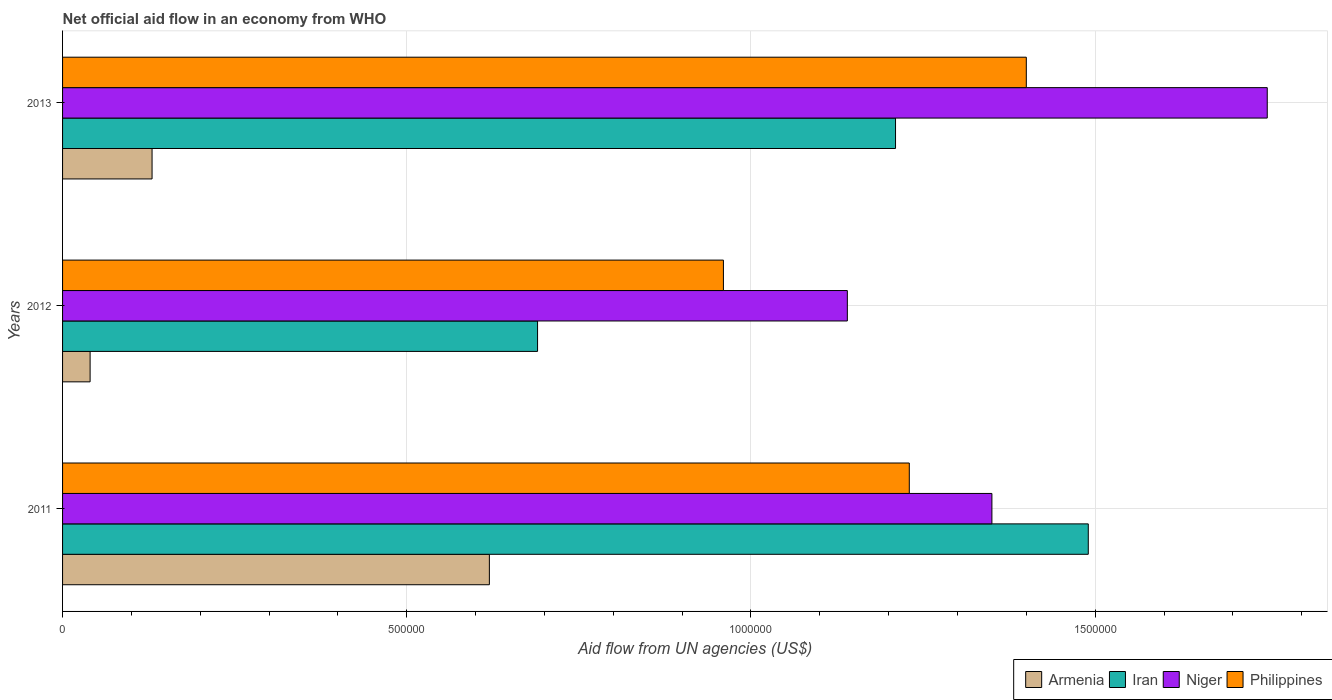How many different coloured bars are there?
Offer a very short reply. 4. Are the number of bars on each tick of the Y-axis equal?
Make the answer very short. Yes. How many bars are there on the 3rd tick from the top?
Give a very brief answer. 4. What is the label of the 3rd group of bars from the top?
Your response must be concise. 2011. What is the net official aid flow in Iran in 2013?
Offer a terse response. 1.21e+06. Across all years, what is the maximum net official aid flow in Iran?
Your answer should be compact. 1.49e+06. Across all years, what is the minimum net official aid flow in Iran?
Give a very brief answer. 6.90e+05. In which year was the net official aid flow in Niger maximum?
Offer a very short reply. 2013. What is the total net official aid flow in Philippines in the graph?
Provide a short and direct response. 3.59e+06. What is the difference between the net official aid flow in Philippines in 2013 and the net official aid flow in Iran in 2012?
Offer a very short reply. 7.10e+05. What is the average net official aid flow in Philippines per year?
Give a very brief answer. 1.20e+06. In the year 2012, what is the difference between the net official aid flow in Armenia and net official aid flow in Niger?
Your answer should be very brief. -1.10e+06. What is the ratio of the net official aid flow in Armenia in 2012 to that in 2013?
Your answer should be compact. 0.31. Is the difference between the net official aid flow in Armenia in 2011 and 2013 greater than the difference between the net official aid flow in Niger in 2011 and 2013?
Offer a very short reply. Yes. What is the difference between the highest and the lowest net official aid flow in Philippines?
Keep it short and to the point. 4.40e+05. What does the 4th bar from the top in 2011 represents?
Give a very brief answer. Armenia. What does the 4th bar from the bottom in 2013 represents?
Your answer should be very brief. Philippines. How many bars are there?
Offer a very short reply. 12. How many years are there in the graph?
Offer a terse response. 3. What is the difference between two consecutive major ticks on the X-axis?
Your response must be concise. 5.00e+05. Does the graph contain grids?
Your response must be concise. Yes. How are the legend labels stacked?
Offer a very short reply. Horizontal. What is the title of the graph?
Provide a short and direct response. Net official aid flow in an economy from WHO. Does "Other small states" appear as one of the legend labels in the graph?
Give a very brief answer. No. What is the label or title of the X-axis?
Provide a succinct answer. Aid flow from UN agencies (US$). What is the Aid flow from UN agencies (US$) of Armenia in 2011?
Your answer should be very brief. 6.20e+05. What is the Aid flow from UN agencies (US$) of Iran in 2011?
Offer a very short reply. 1.49e+06. What is the Aid flow from UN agencies (US$) in Niger in 2011?
Provide a succinct answer. 1.35e+06. What is the Aid flow from UN agencies (US$) in Philippines in 2011?
Make the answer very short. 1.23e+06. What is the Aid flow from UN agencies (US$) of Iran in 2012?
Ensure brevity in your answer.  6.90e+05. What is the Aid flow from UN agencies (US$) of Niger in 2012?
Make the answer very short. 1.14e+06. What is the Aid flow from UN agencies (US$) of Philippines in 2012?
Give a very brief answer. 9.60e+05. What is the Aid flow from UN agencies (US$) in Armenia in 2013?
Ensure brevity in your answer.  1.30e+05. What is the Aid flow from UN agencies (US$) in Iran in 2013?
Your response must be concise. 1.21e+06. What is the Aid flow from UN agencies (US$) in Niger in 2013?
Ensure brevity in your answer.  1.75e+06. What is the Aid flow from UN agencies (US$) of Philippines in 2013?
Offer a terse response. 1.40e+06. Across all years, what is the maximum Aid flow from UN agencies (US$) of Armenia?
Make the answer very short. 6.20e+05. Across all years, what is the maximum Aid flow from UN agencies (US$) in Iran?
Provide a succinct answer. 1.49e+06. Across all years, what is the maximum Aid flow from UN agencies (US$) in Niger?
Ensure brevity in your answer.  1.75e+06. Across all years, what is the maximum Aid flow from UN agencies (US$) of Philippines?
Your answer should be very brief. 1.40e+06. Across all years, what is the minimum Aid flow from UN agencies (US$) in Iran?
Make the answer very short. 6.90e+05. Across all years, what is the minimum Aid flow from UN agencies (US$) in Niger?
Ensure brevity in your answer.  1.14e+06. Across all years, what is the minimum Aid flow from UN agencies (US$) of Philippines?
Your answer should be compact. 9.60e+05. What is the total Aid flow from UN agencies (US$) in Armenia in the graph?
Provide a short and direct response. 7.90e+05. What is the total Aid flow from UN agencies (US$) of Iran in the graph?
Make the answer very short. 3.39e+06. What is the total Aid flow from UN agencies (US$) of Niger in the graph?
Ensure brevity in your answer.  4.24e+06. What is the total Aid flow from UN agencies (US$) of Philippines in the graph?
Ensure brevity in your answer.  3.59e+06. What is the difference between the Aid flow from UN agencies (US$) in Armenia in 2011 and that in 2012?
Offer a terse response. 5.80e+05. What is the difference between the Aid flow from UN agencies (US$) of Iran in 2011 and that in 2012?
Your answer should be very brief. 8.00e+05. What is the difference between the Aid flow from UN agencies (US$) in Philippines in 2011 and that in 2012?
Your answer should be very brief. 2.70e+05. What is the difference between the Aid flow from UN agencies (US$) in Niger in 2011 and that in 2013?
Ensure brevity in your answer.  -4.00e+05. What is the difference between the Aid flow from UN agencies (US$) of Iran in 2012 and that in 2013?
Give a very brief answer. -5.20e+05. What is the difference between the Aid flow from UN agencies (US$) in Niger in 2012 and that in 2013?
Offer a very short reply. -6.10e+05. What is the difference between the Aid flow from UN agencies (US$) in Philippines in 2012 and that in 2013?
Make the answer very short. -4.40e+05. What is the difference between the Aid flow from UN agencies (US$) of Armenia in 2011 and the Aid flow from UN agencies (US$) of Iran in 2012?
Give a very brief answer. -7.00e+04. What is the difference between the Aid flow from UN agencies (US$) of Armenia in 2011 and the Aid flow from UN agencies (US$) of Niger in 2012?
Your answer should be compact. -5.20e+05. What is the difference between the Aid flow from UN agencies (US$) in Armenia in 2011 and the Aid flow from UN agencies (US$) in Philippines in 2012?
Offer a very short reply. -3.40e+05. What is the difference between the Aid flow from UN agencies (US$) of Iran in 2011 and the Aid flow from UN agencies (US$) of Philippines in 2012?
Keep it short and to the point. 5.30e+05. What is the difference between the Aid flow from UN agencies (US$) of Niger in 2011 and the Aid flow from UN agencies (US$) of Philippines in 2012?
Ensure brevity in your answer.  3.90e+05. What is the difference between the Aid flow from UN agencies (US$) in Armenia in 2011 and the Aid flow from UN agencies (US$) in Iran in 2013?
Your response must be concise. -5.90e+05. What is the difference between the Aid flow from UN agencies (US$) of Armenia in 2011 and the Aid flow from UN agencies (US$) of Niger in 2013?
Offer a terse response. -1.13e+06. What is the difference between the Aid flow from UN agencies (US$) in Armenia in 2011 and the Aid flow from UN agencies (US$) in Philippines in 2013?
Offer a terse response. -7.80e+05. What is the difference between the Aid flow from UN agencies (US$) of Iran in 2011 and the Aid flow from UN agencies (US$) of Philippines in 2013?
Provide a short and direct response. 9.00e+04. What is the difference between the Aid flow from UN agencies (US$) of Armenia in 2012 and the Aid flow from UN agencies (US$) of Iran in 2013?
Offer a terse response. -1.17e+06. What is the difference between the Aid flow from UN agencies (US$) in Armenia in 2012 and the Aid flow from UN agencies (US$) in Niger in 2013?
Ensure brevity in your answer.  -1.71e+06. What is the difference between the Aid flow from UN agencies (US$) of Armenia in 2012 and the Aid flow from UN agencies (US$) of Philippines in 2013?
Your answer should be compact. -1.36e+06. What is the difference between the Aid flow from UN agencies (US$) in Iran in 2012 and the Aid flow from UN agencies (US$) in Niger in 2013?
Provide a short and direct response. -1.06e+06. What is the difference between the Aid flow from UN agencies (US$) in Iran in 2012 and the Aid flow from UN agencies (US$) in Philippines in 2013?
Offer a very short reply. -7.10e+05. What is the average Aid flow from UN agencies (US$) in Armenia per year?
Provide a short and direct response. 2.63e+05. What is the average Aid flow from UN agencies (US$) of Iran per year?
Your answer should be very brief. 1.13e+06. What is the average Aid flow from UN agencies (US$) of Niger per year?
Your answer should be very brief. 1.41e+06. What is the average Aid flow from UN agencies (US$) of Philippines per year?
Offer a terse response. 1.20e+06. In the year 2011, what is the difference between the Aid flow from UN agencies (US$) of Armenia and Aid flow from UN agencies (US$) of Iran?
Give a very brief answer. -8.70e+05. In the year 2011, what is the difference between the Aid flow from UN agencies (US$) of Armenia and Aid flow from UN agencies (US$) of Niger?
Give a very brief answer. -7.30e+05. In the year 2011, what is the difference between the Aid flow from UN agencies (US$) of Armenia and Aid flow from UN agencies (US$) of Philippines?
Offer a very short reply. -6.10e+05. In the year 2011, what is the difference between the Aid flow from UN agencies (US$) of Niger and Aid flow from UN agencies (US$) of Philippines?
Offer a terse response. 1.20e+05. In the year 2012, what is the difference between the Aid flow from UN agencies (US$) of Armenia and Aid flow from UN agencies (US$) of Iran?
Provide a succinct answer. -6.50e+05. In the year 2012, what is the difference between the Aid flow from UN agencies (US$) in Armenia and Aid flow from UN agencies (US$) in Niger?
Offer a very short reply. -1.10e+06. In the year 2012, what is the difference between the Aid flow from UN agencies (US$) of Armenia and Aid flow from UN agencies (US$) of Philippines?
Your answer should be compact. -9.20e+05. In the year 2012, what is the difference between the Aid flow from UN agencies (US$) of Iran and Aid flow from UN agencies (US$) of Niger?
Your answer should be compact. -4.50e+05. In the year 2013, what is the difference between the Aid flow from UN agencies (US$) in Armenia and Aid flow from UN agencies (US$) in Iran?
Your answer should be very brief. -1.08e+06. In the year 2013, what is the difference between the Aid flow from UN agencies (US$) of Armenia and Aid flow from UN agencies (US$) of Niger?
Your response must be concise. -1.62e+06. In the year 2013, what is the difference between the Aid flow from UN agencies (US$) in Armenia and Aid flow from UN agencies (US$) in Philippines?
Provide a short and direct response. -1.27e+06. In the year 2013, what is the difference between the Aid flow from UN agencies (US$) of Iran and Aid flow from UN agencies (US$) of Niger?
Keep it short and to the point. -5.40e+05. In the year 2013, what is the difference between the Aid flow from UN agencies (US$) in Iran and Aid flow from UN agencies (US$) in Philippines?
Make the answer very short. -1.90e+05. In the year 2013, what is the difference between the Aid flow from UN agencies (US$) of Niger and Aid flow from UN agencies (US$) of Philippines?
Keep it short and to the point. 3.50e+05. What is the ratio of the Aid flow from UN agencies (US$) of Iran in 2011 to that in 2012?
Offer a terse response. 2.16. What is the ratio of the Aid flow from UN agencies (US$) in Niger in 2011 to that in 2012?
Make the answer very short. 1.18. What is the ratio of the Aid flow from UN agencies (US$) of Philippines in 2011 to that in 2012?
Give a very brief answer. 1.28. What is the ratio of the Aid flow from UN agencies (US$) in Armenia in 2011 to that in 2013?
Provide a succinct answer. 4.77. What is the ratio of the Aid flow from UN agencies (US$) of Iran in 2011 to that in 2013?
Your answer should be very brief. 1.23. What is the ratio of the Aid flow from UN agencies (US$) in Niger in 2011 to that in 2013?
Offer a terse response. 0.77. What is the ratio of the Aid flow from UN agencies (US$) of Philippines in 2011 to that in 2013?
Your response must be concise. 0.88. What is the ratio of the Aid flow from UN agencies (US$) of Armenia in 2012 to that in 2013?
Make the answer very short. 0.31. What is the ratio of the Aid flow from UN agencies (US$) in Iran in 2012 to that in 2013?
Your response must be concise. 0.57. What is the ratio of the Aid flow from UN agencies (US$) in Niger in 2012 to that in 2013?
Provide a succinct answer. 0.65. What is the ratio of the Aid flow from UN agencies (US$) of Philippines in 2012 to that in 2013?
Offer a very short reply. 0.69. What is the difference between the highest and the second highest Aid flow from UN agencies (US$) in Armenia?
Your answer should be very brief. 4.90e+05. What is the difference between the highest and the lowest Aid flow from UN agencies (US$) of Armenia?
Your response must be concise. 5.80e+05. What is the difference between the highest and the lowest Aid flow from UN agencies (US$) in Niger?
Make the answer very short. 6.10e+05. What is the difference between the highest and the lowest Aid flow from UN agencies (US$) in Philippines?
Provide a succinct answer. 4.40e+05. 